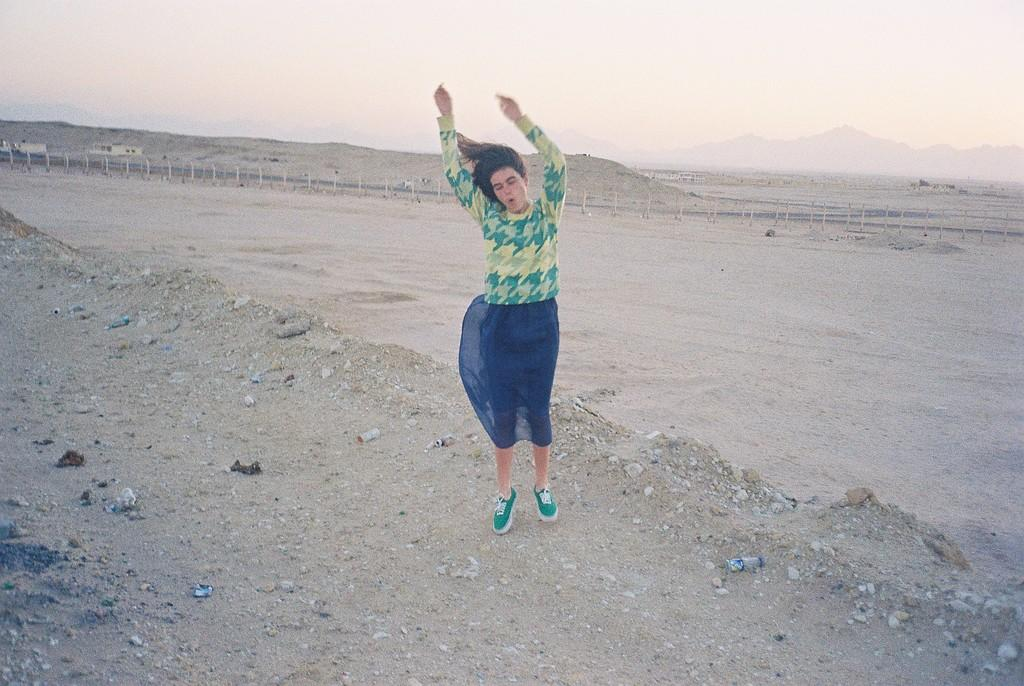What is the general appearance of the background in the image? The background of the image is blurred. What part of the natural environment can be seen in the image? There is a sky visible in the image. What structures are present in the image? There are poles in the image. What type of landscape is depicted in the image? There are hills in the image. What action is the woman in the image performing? A woman is jumping in the image. How does the woman's digestion affect the image? The woman's digestion is not visible or relevant in the image, so it cannot affect the image. 